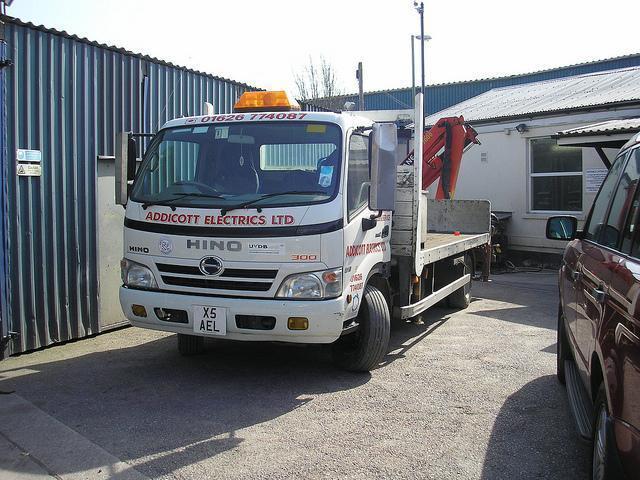How many vehicles are in the picture?
Give a very brief answer. 2. 